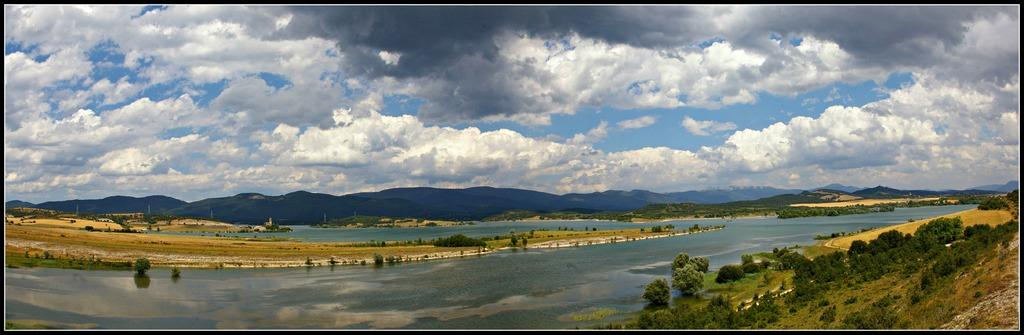What is the main feature of the landscape in the image? There is a large water body in the image. What type of vegetation can be seen on the land in the image? There are trees on the land in the image. What structures are visible in the image? There are poles visible in the image. What geographical feature is present in the background of the image? There are mountains in the image. How would you describe the sky in the image? The sky is visible in the image and appears cloudy. What color of paint is being used to create the spring in the image? There is no spring or paint present in the image. 